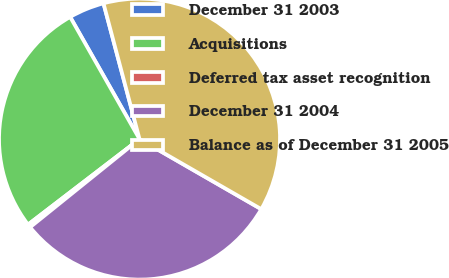<chart> <loc_0><loc_0><loc_500><loc_500><pie_chart><fcel>December 31 2003<fcel>Acquisitions<fcel>Deferred tax asset recognition<fcel>December 31 2004<fcel>Balance as of December 31 2005<nl><fcel>4.09%<fcel>27.19%<fcel>0.38%<fcel>30.9%<fcel>37.44%<nl></chart> 